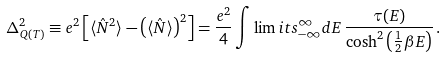<formula> <loc_0><loc_0><loc_500><loc_500>\Delta ^ { 2 } _ { Q ( T ) } \equiv e ^ { 2 } \left [ \langle \hat { N } ^ { 2 } \rangle - \left ( \langle \hat { N } \rangle \right ) ^ { 2 } \right ] = \frac { e ^ { 2 } } { 4 } \int \lim i t s _ { - \infty } ^ { \infty } d E \, \frac { \tau ( E ) } { \cosh ^ { 2 } \left ( \frac { 1 } { 2 } \beta E \right ) } \, .</formula> 